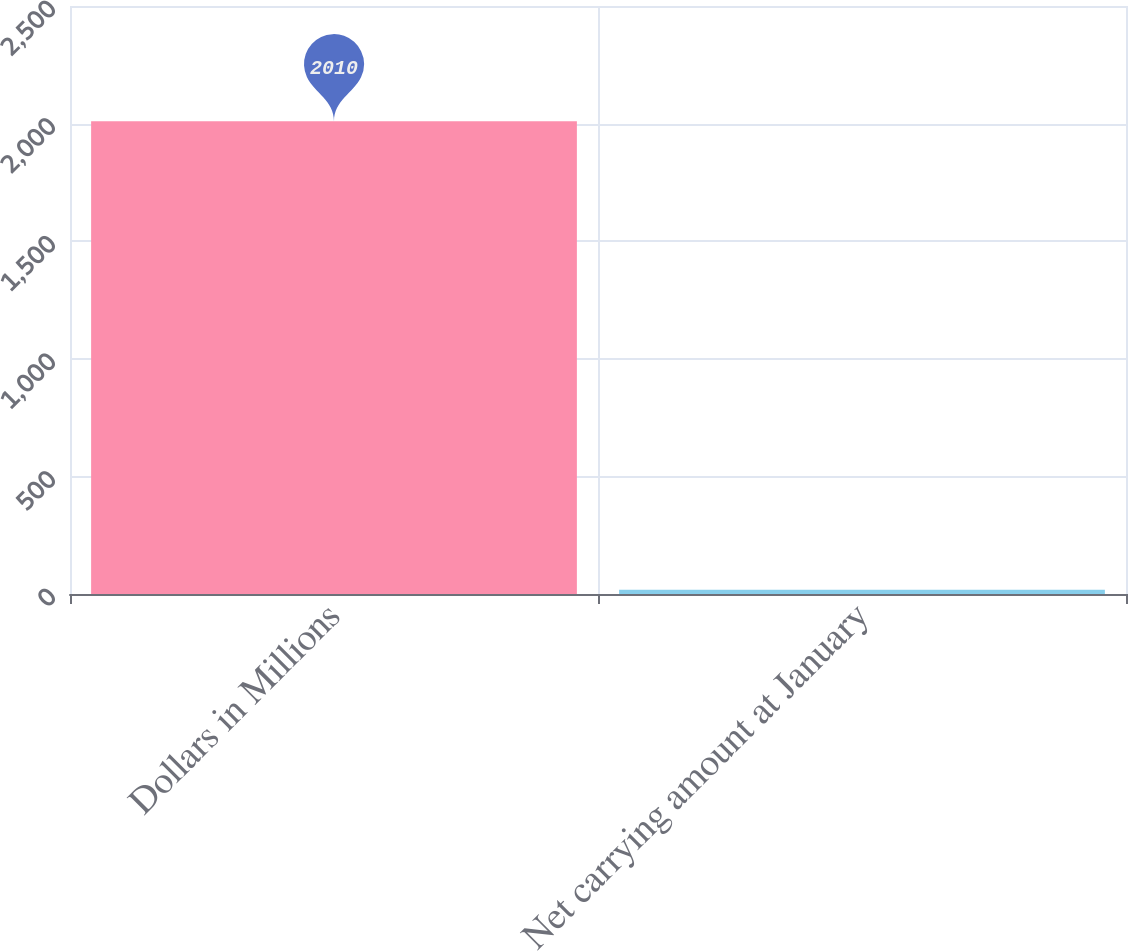Convert chart to OTSL. <chart><loc_0><loc_0><loc_500><loc_500><bar_chart><fcel>Dollars in Millions<fcel>Net carrying amount at January<nl><fcel>2010<fcel>18<nl></chart> 